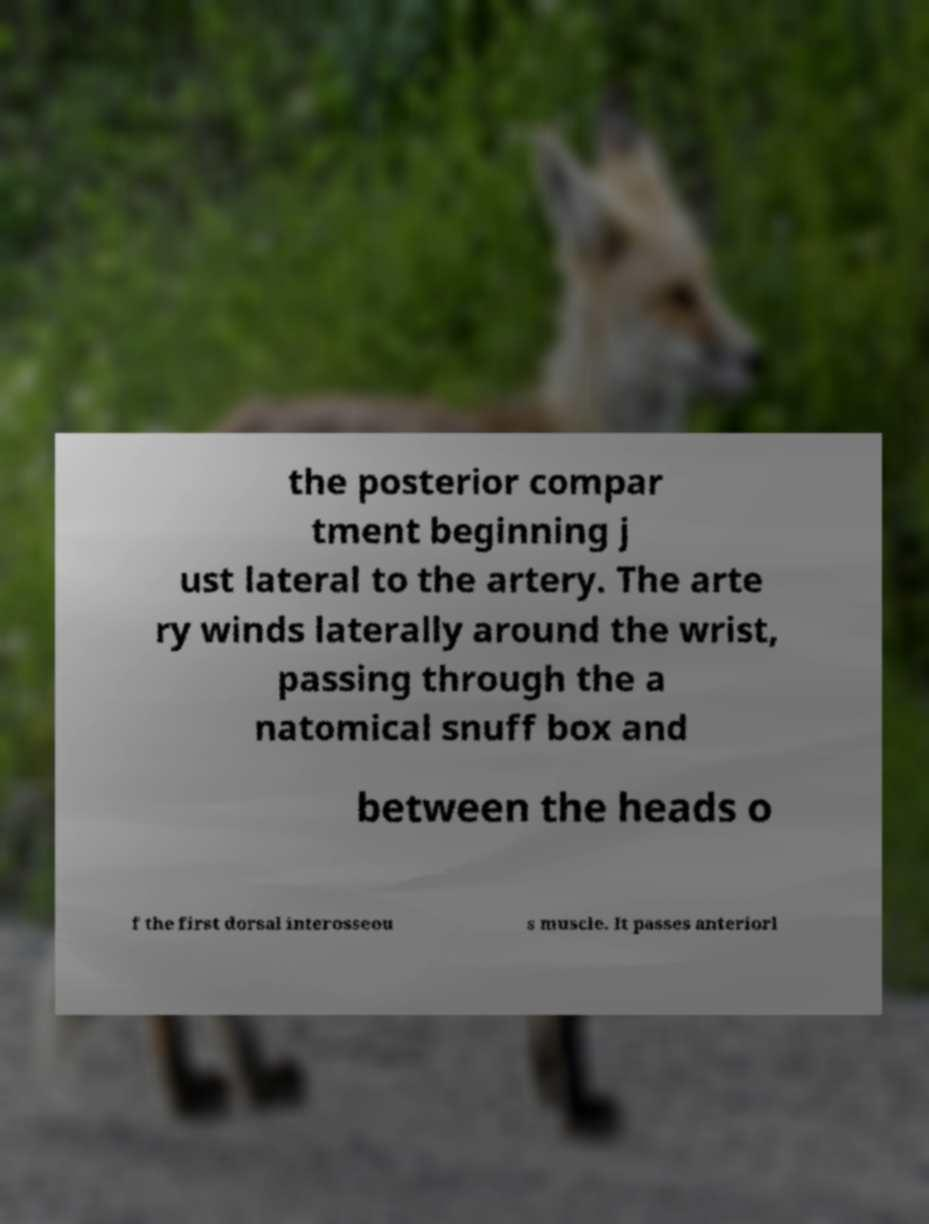Please read and relay the text visible in this image. What does it say? the posterior compar tment beginning j ust lateral to the artery. The arte ry winds laterally around the wrist, passing through the a natomical snuff box and between the heads o f the first dorsal interosseou s muscle. It passes anteriorl 